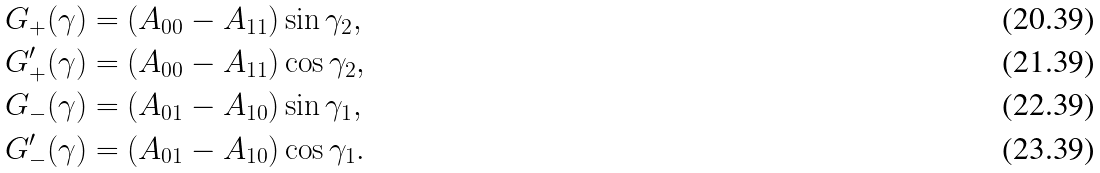<formula> <loc_0><loc_0><loc_500><loc_500>G _ { + } ( \gamma ) & = ( A _ { 0 0 } - A _ { 1 1 } ) \sin { \gamma _ { 2 } } , \\ G _ { + } ^ { \prime } ( \gamma ) & = ( A _ { 0 0 } - A _ { 1 1 } ) \cos { \gamma _ { 2 } } , \\ G _ { - } ( \gamma ) & = ( A _ { 0 1 } - A _ { 1 0 } ) \sin { \gamma _ { 1 } } , \\ G _ { - } ^ { \prime } ( \gamma ) & = ( A _ { 0 1 } - A _ { 1 0 } ) \cos { \gamma _ { 1 } } .</formula> 